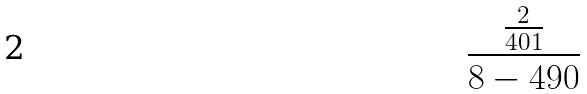Convert formula to latex. <formula><loc_0><loc_0><loc_500><loc_500>\frac { \frac { 2 } { 4 0 1 } } { 8 - 4 9 0 }</formula> 